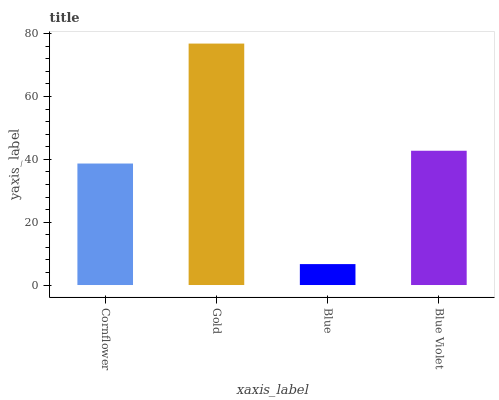Is Blue the minimum?
Answer yes or no. Yes. Is Gold the maximum?
Answer yes or no. Yes. Is Gold the minimum?
Answer yes or no. No. Is Blue the maximum?
Answer yes or no. No. Is Gold greater than Blue?
Answer yes or no. Yes. Is Blue less than Gold?
Answer yes or no. Yes. Is Blue greater than Gold?
Answer yes or no. No. Is Gold less than Blue?
Answer yes or no. No. Is Blue Violet the high median?
Answer yes or no. Yes. Is Cornflower the low median?
Answer yes or no. Yes. Is Cornflower the high median?
Answer yes or no. No. Is Blue Violet the low median?
Answer yes or no. No. 